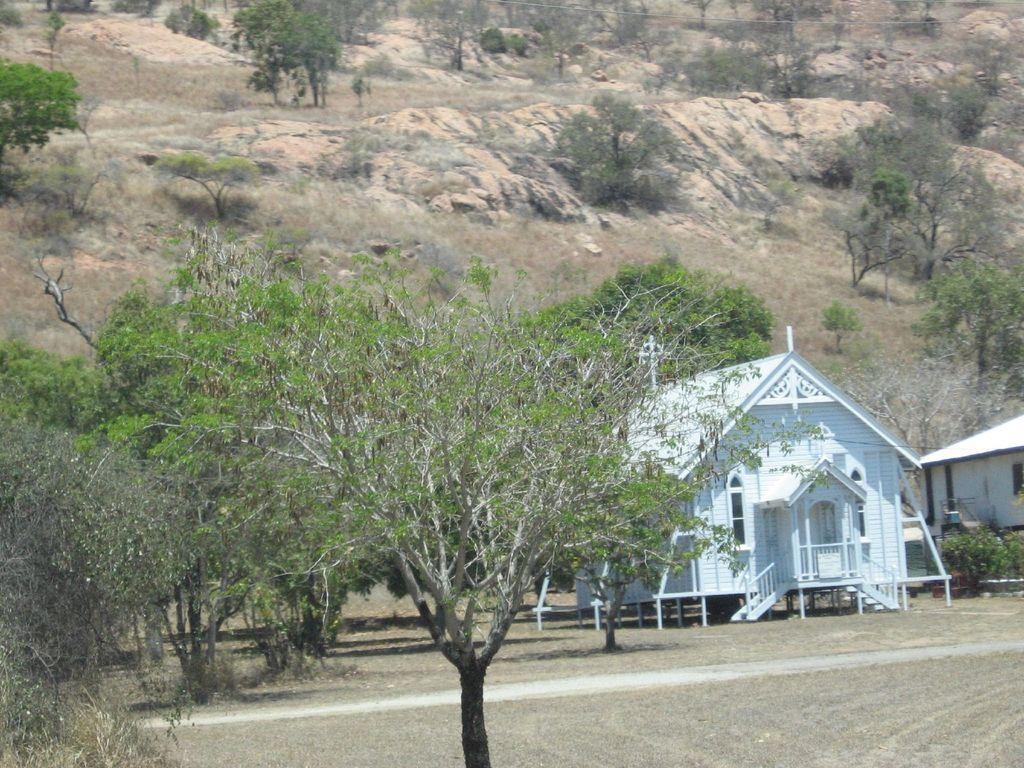In one or two sentences, can you explain what this image depicts? In this picture we can see the ground, houses, plants, trees and some objects and in the background we can see rocks. 